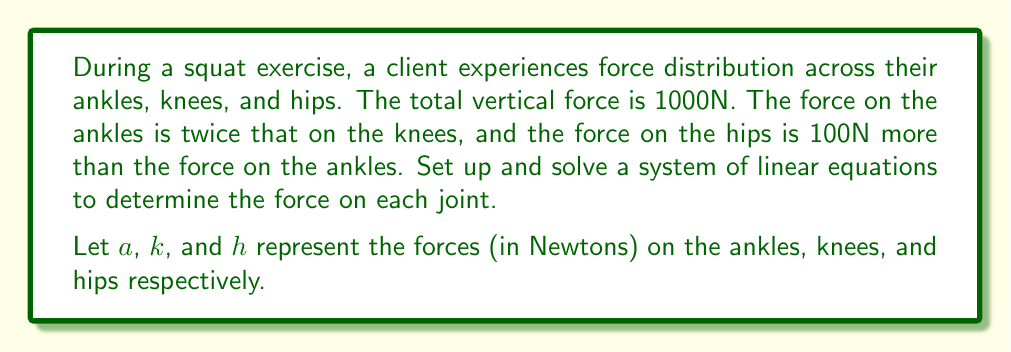Can you solve this math problem? Let's set up the system of linear equations based on the given information:

1. Total force equation:
   $a + k + h = 1000$

2. Relationship between ankle and knee forces:
   $a = 2k$

3. Relationship between hip and ankle forces:
   $h = a + 100$

Now, let's solve this system step by step:

Step 1: Substitute the second equation into the first:
$2k + k + h = 1000$
$3k + h = 1000$ ... (Equation A)

Step 2: Substitute the third equation into Equation A:
$3k + (a + 100) = 1000$
$3k + (2k + 100) = 1000$ (using $a = 2k$ from the second equation)
$3k + 2k + 100 = 1000$
$5k + 100 = 1000$

Step 3: Solve for $k$:
$5k = 900$
$k = 180$

Step 4: Calculate $a$ using the second equation:
$a = 2k = 2(180) = 360$

Step 5: Calculate $h$ using the third equation:
$h = a + 100 = 360 + 100 = 460$

Let's verify that these values satisfy the total force equation:
$a + k + h = 360 + 180 + 460 = 1000$

Therefore, the forces are distributed as follows:
Ankles (a): 360N
Knees (k): 180N
Hips (h): 460N
Answer: Ankles: 360N
Knees: 180N
Hips: 460N 